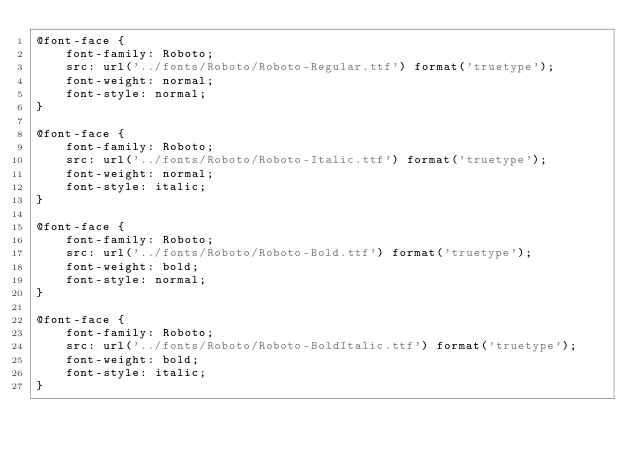<code> <loc_0><loc_0><loc_500><loc_500><_CSS_>@font-face {
    font-family: Roboto;
    src: url('../fonts/Roboto/Roboto-Regular.ttf') format('truetype');
    font-weight: normal;
    font-style: normal;
}

@font-face {
    font-family: Roboto;
    src: url('../fonts/Roboto/Roboto-Italic.ttf') format('truetype');
    font-weight: normal;
    font-style: italic;
}

@font-face {
    font-family: Roboto;
    src: url('../fonts/Roboto/Roboto-Bold.ttf') format('truetype');
    font-weight: bold;
    font-style: normal;
}

@font-face {
    font-family: Roboto;
    src: url('../fonts/Roboto/Roboto-BoldItalic.ttf') format('truetype');
    font-weight: bold;
    font-style: italic;
}</code> 